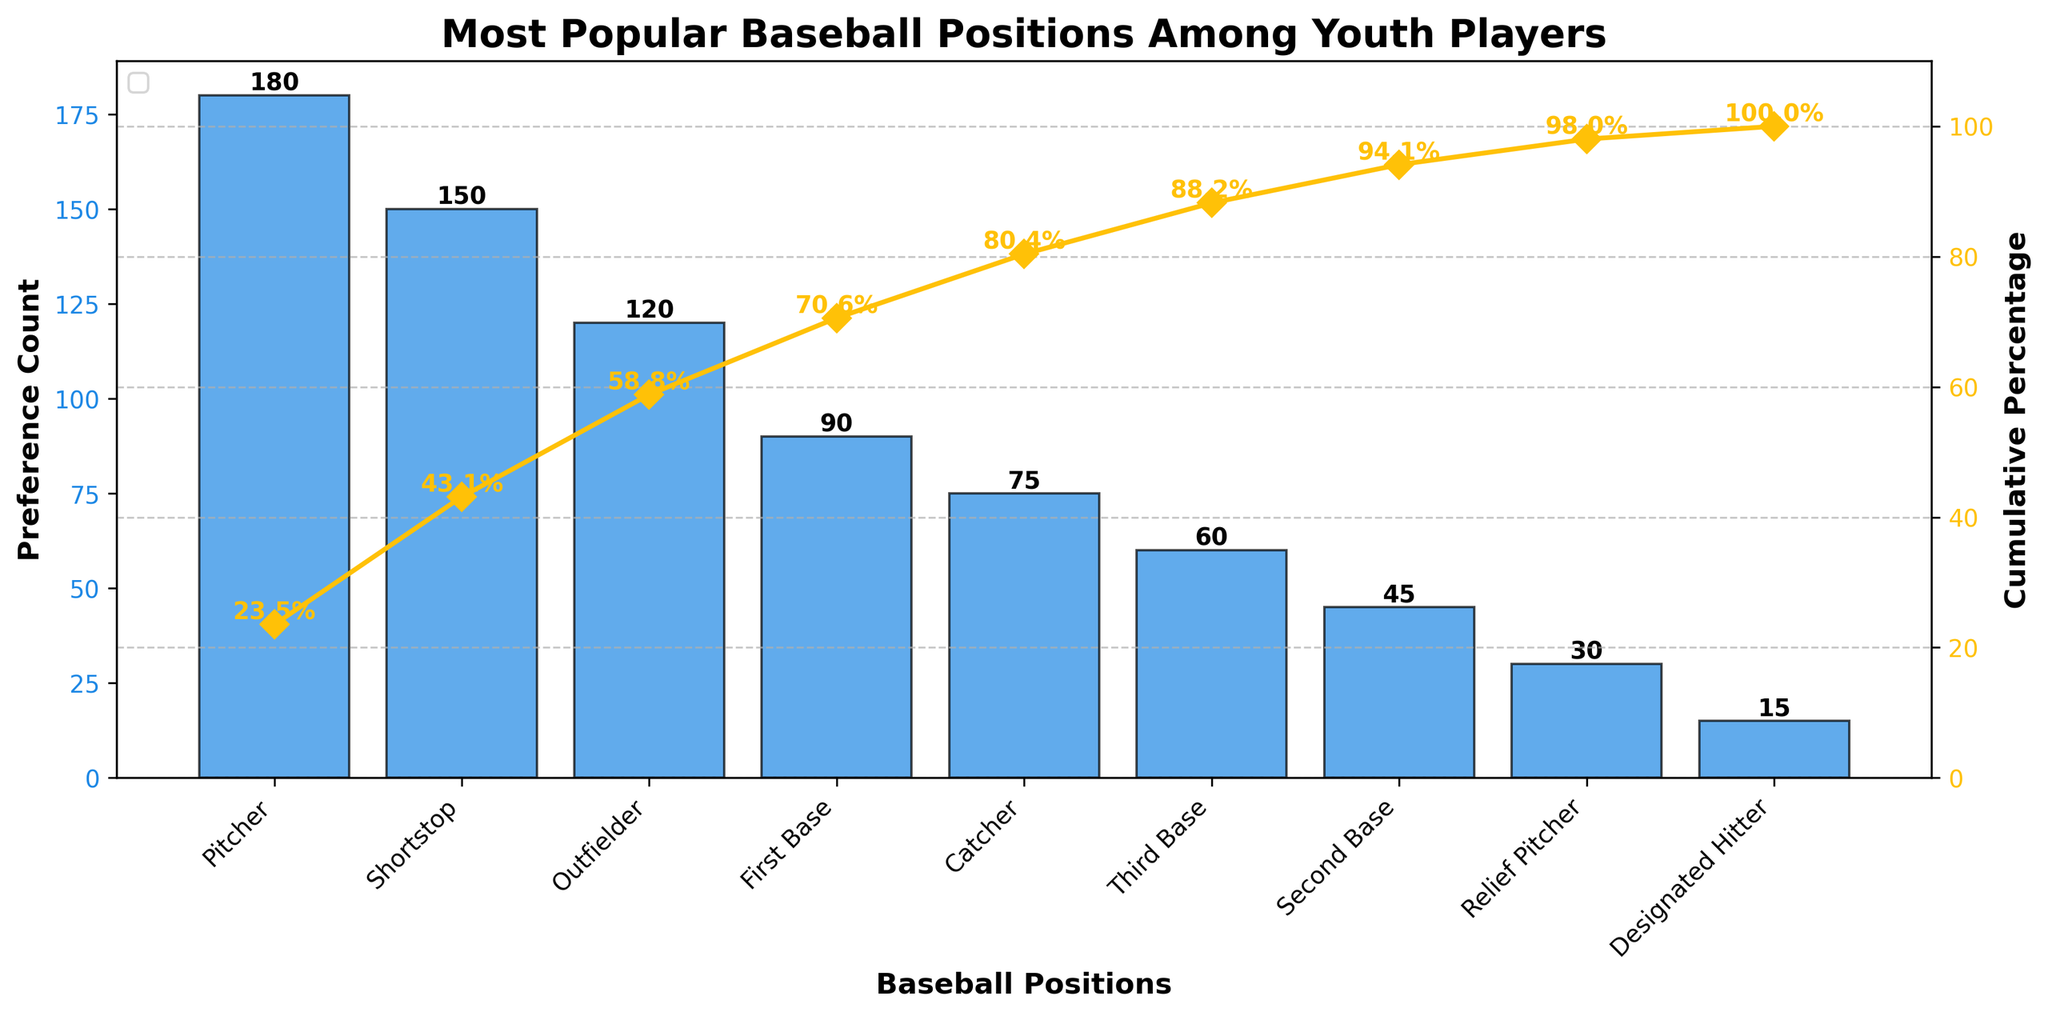Which baseball position has the highest preference count? The tallest bar in the Pareto chart represents the position with the highest preference count. This bar is labeled as "Pitcher" with a count of 180.
Answer: Pitcher How many baseball positions are shown in the chart? Each bar represents a single baseball position, so we count the number of bars to determine the total number. There are nine bars in the chart.
Answer: 9 What is the cumulative percentage when adding Relief Pitcher? First, identify the order of positions: Relief Pitcher is the second to last. Sum the counts from the first to Relief Pitcher: (180 + 150 + 120 + 90 + 75 + 60 + 45 + 30). Calculate the cumulative percentage relative to the total sum: (750 / 765) * 100 = 98.04%.
Answer: 98.04% Which position is preferred more, Third Base or Catcher? Compare the heights of the bars labeled "Third Base" and "Catcher". The Catcher bar is higher with a preference count of 75, while Third Base has 60.
Answer: Catcher What color represents the bars for preference counts? Observe the color of the bars in the chart. All the bars are colored in blue.
Answer: Blue What is the cumulative percentage for Designated Hitter? Find the cumulative sum up to Designated Hitter (last position): 765. The total sum is also 765, so the cumulative percentage is (765 / 765) * 100 = 100%.
Answer: 100% Which position is just after Shortstop in terms of preference count? Find Shortstop and look at the next bar in descending order. The bar immediately after Shortstop, with a lower height than Shortstop, is Outfielder with 120 counts.
Answer: Outfielder How does the cumulative percentage change between Second Base and Relief Pitcher? First, identify the cumulative percentages for both: Second Base (92.2%) and Relief Pitcher (96.1%). Calculate the difference: 96.1% - 92.2% = 3.9%.
Answer: 3.9% What is the difference in preference counts between Outfielder and First Base? Identify the counts for both positions: Outfielder (120) and First Base (90). Subtract First Base from Outfielder: 120 - 90 = 30.
Answer: 30 